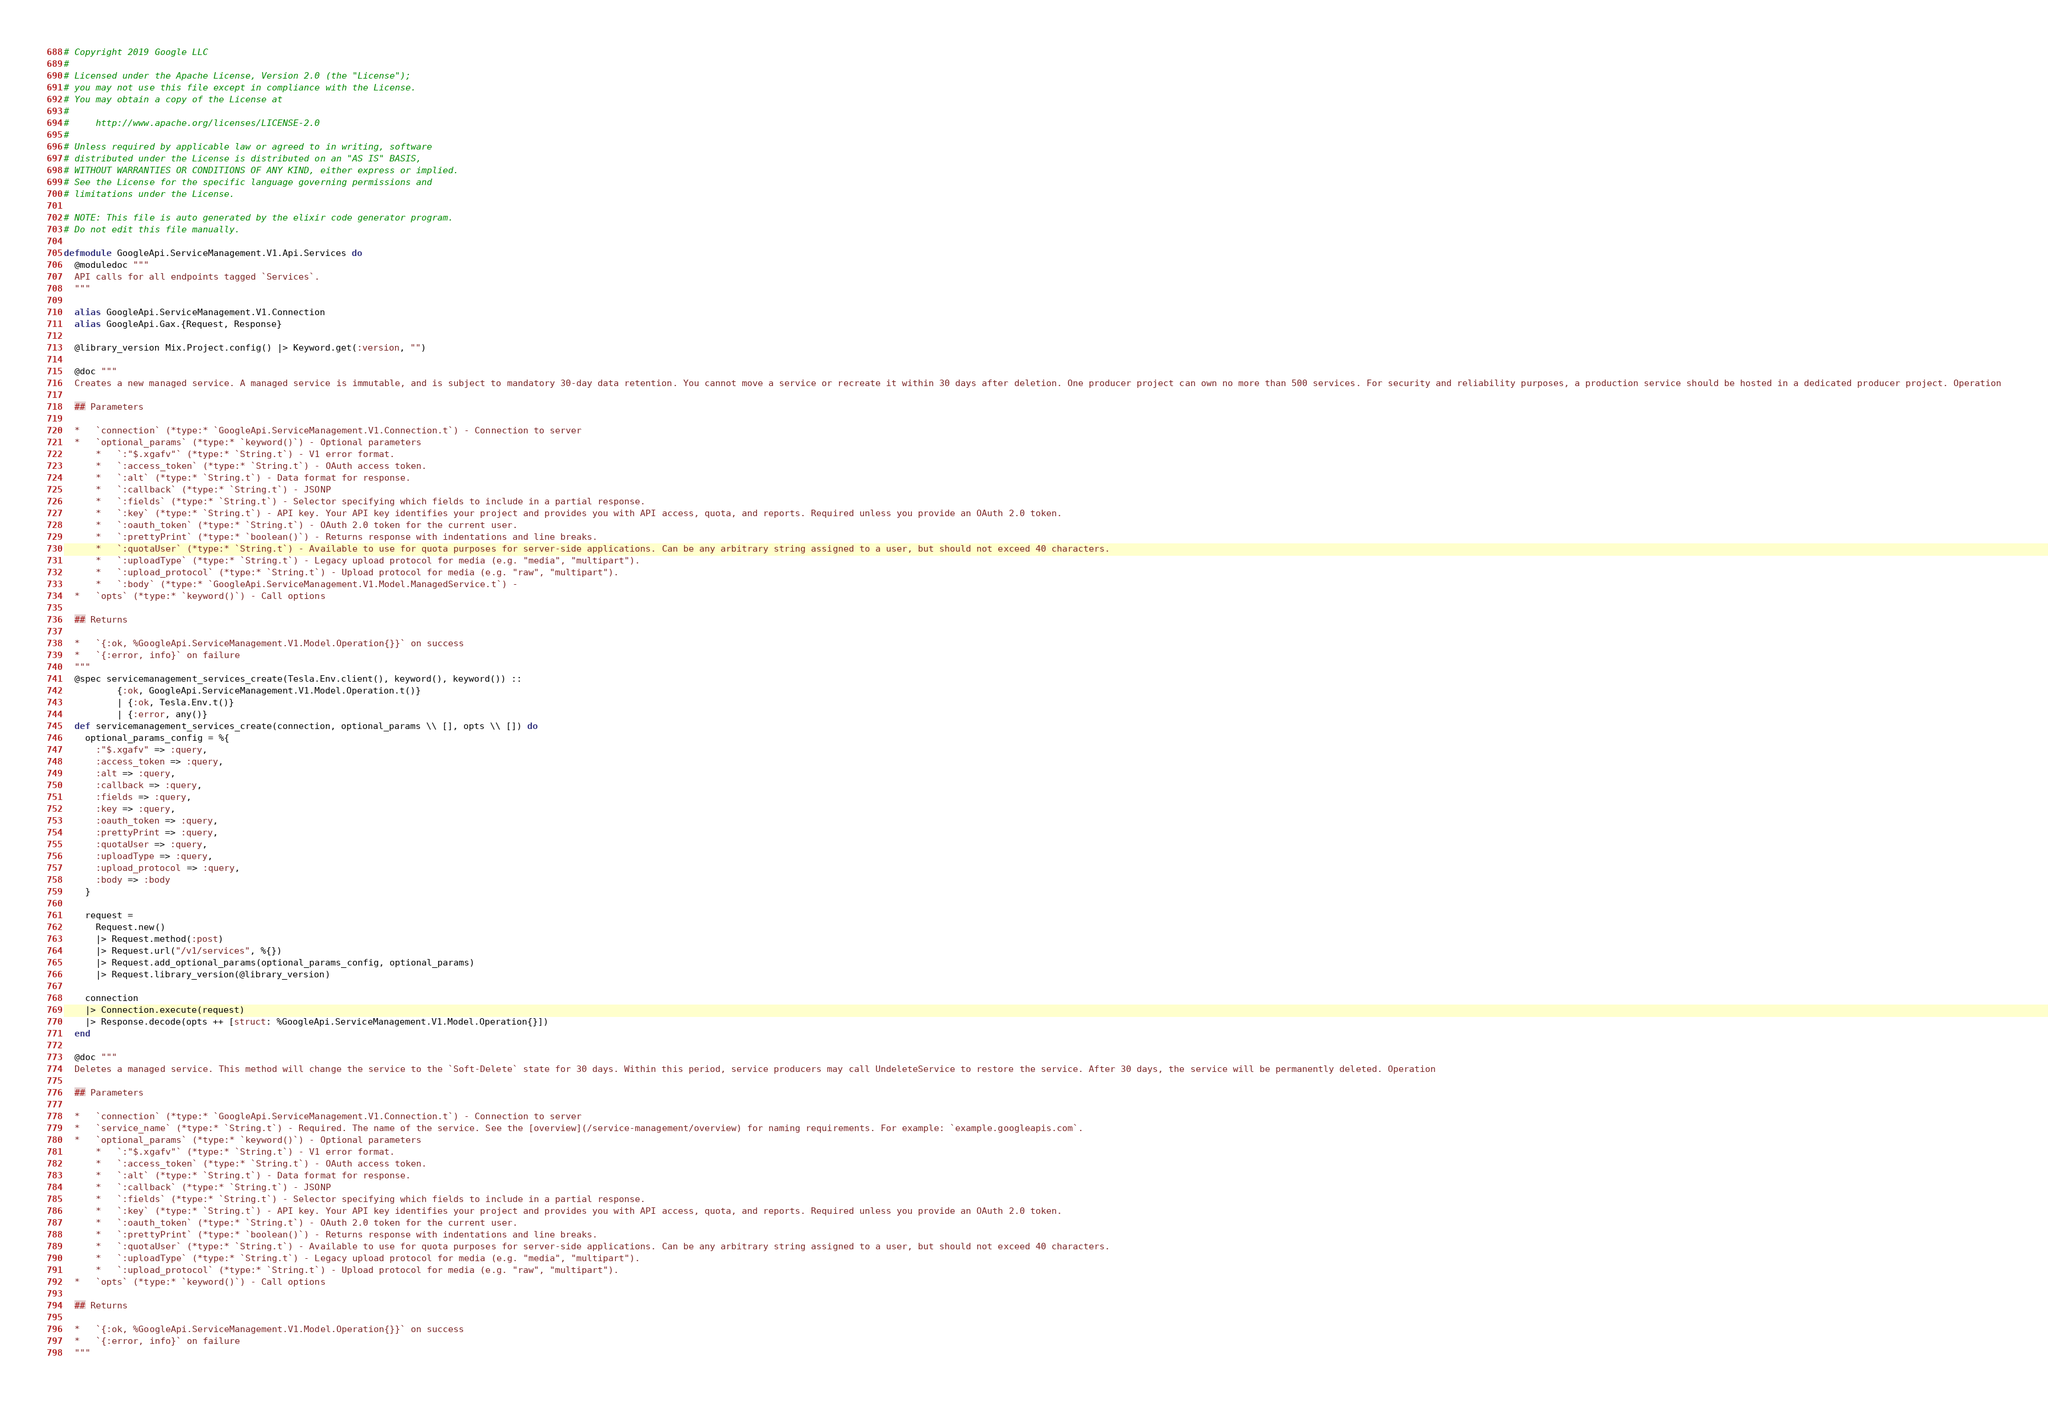<code> <loc_0><loc_0><loc_500><loc_500><_Elixir_># Copyright 2019 Google LLC
#
# Licensed under the Apache License, Version 2.0 (the "License");
# you may not use this file except in compliance with the License.
# You may obtain a copy of the License at
#
#     http://www.apache.org/licenses/LICENSE-2.0
#
# Unless required by applicable law or agreed to in writing, software
# distributed under the License is distributed on an "AS IS" BASIS,
# WITHOUT WARRANTIES OR CONDITIONS OF ANY KIND, either express or implied.
# See the License for the specific language governing permissions and
# limitations under the License.

# NOTE: This file is auto generated by the elixir code generator program.
# Do not edit this file manually.

defmodule GoogleApi.ServiceManagement.V1.Api.Services do
  @moduledoc """
  API calls for all endpoints tagged `Services`.
  """

  alias GoogleApi.ServiceManagement.V1.Connection
  alias GoogleApi.Gax.{Request, Response}

  @library_version Mix.Project.config() |> Keyword.get(:version, "")

  @doc """
  Creates a new managed service. A managed service is immutable, and is subject to mandatory 30-day data retention. You cannot move a service or recreate it within 30 days after deletion. One producer project can own no more than 500 services. For security and reliability purposes, a production service should be hosted in a dedicated producer project. Operation

  ## Parameters

  *   `connection` (*type:* `GoogleApi.ServiceManagement.V1.Connection.t`) - Connection to server
  *   `optional_params` (*type:* `keyword()`) - Optional parameters
      *   `:"$.xgafv"` (*type:* `String.t`) - V1 error format.
      *   `:access_token` (*type:* `String.t`) - OAuth access token.
      *   `:alt` (*type:* `String.t`) - Data format for response.
      *   `:callback` (*type:* `String.t`) - JSONP
      *   `:fields` (*type:* `String.t`) - Selector specifying which fields to include in a partial response.
      *   `:key` (*type:* `String.t`) - API key. Your API key identifies your project and provides you with API access, quota, and reports. Required unless you provide an OAuth 2.0 token.
      *   `:oauth_token` (*type:* `String.t`) - OAuth 2.0 token for the current user.
      *   `:prettyPrint` (*type:* `boolean()`) - Returns response with indentations and line breaks.
      *   `:quotaUser` (*type:* `String.t`) - Available to use for quota purposes for server-side applications. Can be any arbitrary string assigned to a user, but should not exceed 40 characters.
      *   `:uploadType` (*type:* `String.t`) - Legacy upload protocol for media (e.g. "media", "multipart").
      *   `:upload_protocol` (*type:* `String.t`) - Upload protocol for media (e.g. "raw", "multipart").
      *   `:body` (*type:* `GoogleApi.ServiceManagement.V1.Model.ManagedService.t`) - 
  *   `opts` (*type:* `keyword()`) - Call options

  ## Returns

  *   `{:ok, %GoogleApi.ServiceManagement.V1.Model.Operation{}}` on success
  *   `{:error, info}` on failure
  """
  @spec servicemanagement_services_create(Tesla.Env.client(), keyword(), keyword()) ::
          {:ok, GoogleApi.ServiceManagement.V1.Model.Operation.t()}
          | {:ok, Tesla.Env.t()}
          | {:error, any()}
  def servicemanagement_services_create(connection, optional_params \\ [], opts \\ []) do
    optional_params_config = %{
      :"$.xgafv" => :query,
      :access_token => :query,
      :alt => :query,
      :callback => :query,
      :fields => :query,
      :key => :query,
      :oauth_token => :query,
      :prettyPrint => :query,
      :quotaUser => :query,
      :uploadType => :query,
      :upload_protocol => :query,
      :body => :body
    }

    request =
      Request.new()
      |> Request.method(:post)
      |> Request.url("/v1/services", %{})
      |> Request.add_optional_params(optional_params_config, optional_params)
      |> Request.library_version(@library_version)

    connection
    |> Connection.execute(request)
    |> Response.decode(opts ++ [struct: %GoogleApi.ServiceManagement.V1.Model.Operation{}])
  end

  @doc """
  Deletes a managed service. This method will change the service to the `Soft-Delete` state for 30 days. Within this period, service producers may call UndeleteService to restore the service. After 30 days, the service will be permanently deleted. Operation

  ## Parameters

  *   `connection` (*type:* `GoogleApi.ServiceManagement.V1.Connection.t`) - Connection to server
  *   `service_name` (*type:* `String.t`) - Required. The name of the service. See the [overview](/service-management/overview) for naming requirements. For example: `example.googleapis.com`.
  *   `optional_params` (*type:* `keyword()`) - Optional parameters
      *   `:"$.xgafv"` (*type:* `String.t`) - V1 error format.
      *   `:access_token` (*type:* `String.t`) - OAuth access token.
      *   `:alt` (*type:* `String.t`) - Data format for response.
      *   `:callback` (*type:* `String.t`) - JSONP
      *   `:fields` (*type:* `String.t`) - Selector specifying which fields to include in a partial response.
      *   `:key` (*type:* `String.t`) - API key. Your API key identifies your project and provides you with API access, quota, and reports. Required unless you provide an OAuth 2.0 token.
      *   `:oauth_token` (*type:* `String.t`) - OAuth 2.0 token for the current user.
      *   `:prettyPrint` (*type:* `boolean()`) - Returns response with indentations and line breaks.
      *   `:quotaUser` (*type:* `String.t`) - Available to use for quota purposes for server-side applications. Can be any arbitrary string assigned to a user, but should not exceed 40 characters.
      *   `:uploadType` (*type:* `String.t`) - Legacy upload protocol for media (e.g. "media", "multipart").
      *   `:upload_protocol` (*type:* `String.t`) - Upload protocol for media (e.g. "raw", "multipart").
  *   `opts` (*type:* `keyword()`) - Call options

  ## Returns

  *   `{:ok, %GoogleApi.ServiceManagement.V1.Model.Operation{}}` on success
  *   `{:error, info}` on failure
  """</code> 